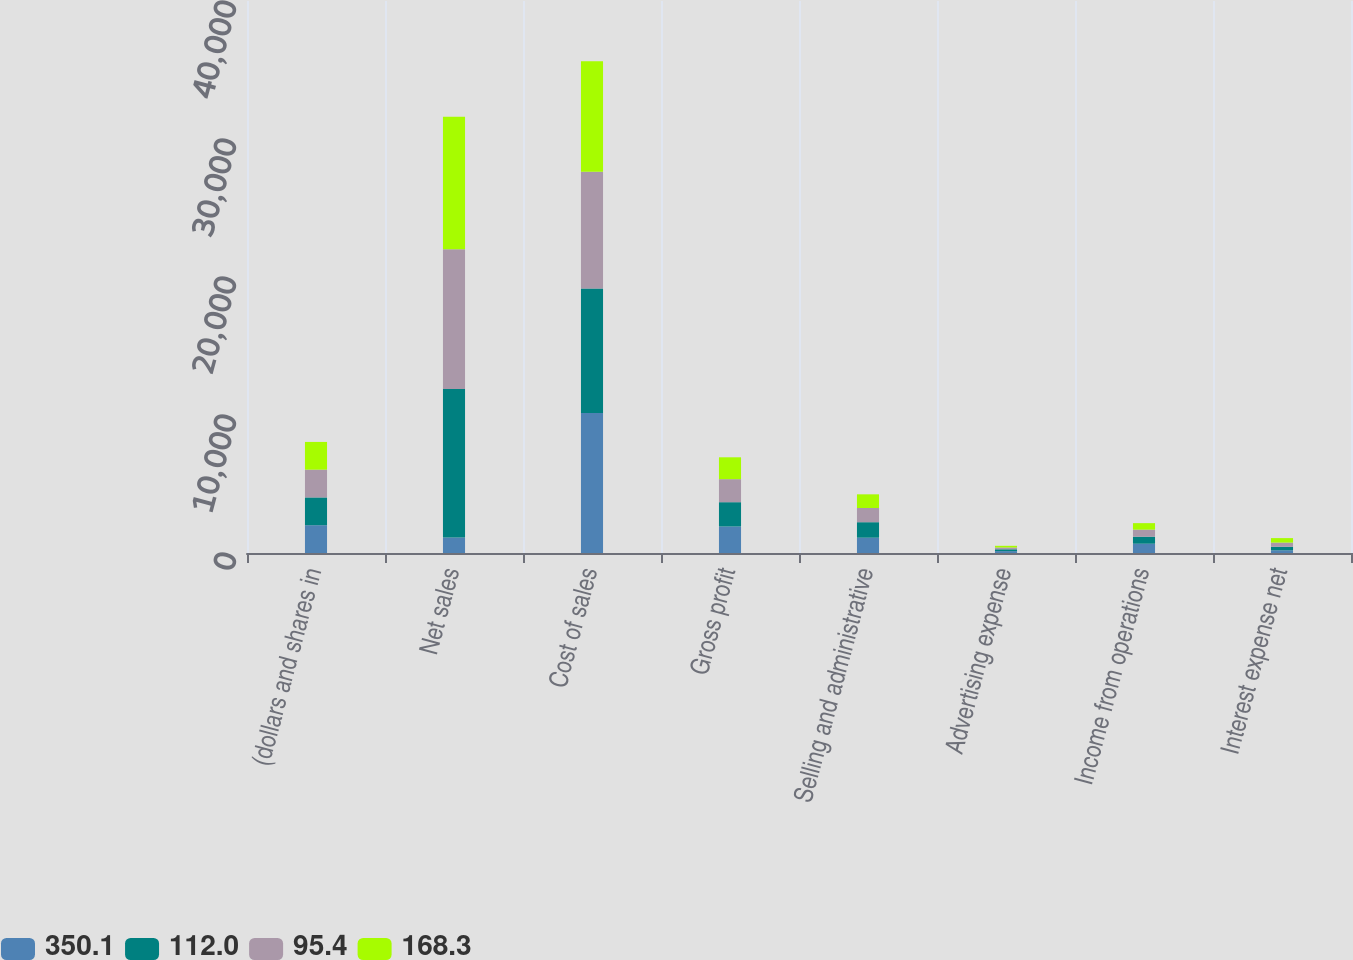Convert chart to OTSL. <chart><loc_0><loc_0><loc_500><loc_500><stacked_bar_chart><ecel><fcel>(dollars and shares in<fcel>Net sales<fcel>Cost of sales<fcel>Gross profit<fcel>Selling and administrative<fcel>Advertising expense<fcel>Income from operations<fcel>Interest expense net<nl><fcel>350.1<fcel>2014<fcel>1120.9<fcel>10153.2<fcel>1921.3<fcel>1110.3<fcel>138<fcel>673<fcel>197.3<nl><fcel>112<fcel>2013<fcel>10768.6<fcel>9008.3<fcel>1760.3<fcel>1120.9<fcel>130.8<fcel>508.6<fcel>250.1<nl><fcel>95.4<fcel>2012<fcel>10128.2<fcel>8458.6<fcel>1669.6<fcel>1029.5<fcel>129.5<fcel>510.6<fcel>307.4<nl><fcel>168.3<fcel>2011<fcel>9602.4<fcel>8018.9<fcel>1583.5<fcel>990.1<fcel>122.7<fcel>470.7<fcel>324.2<nl></chart> 